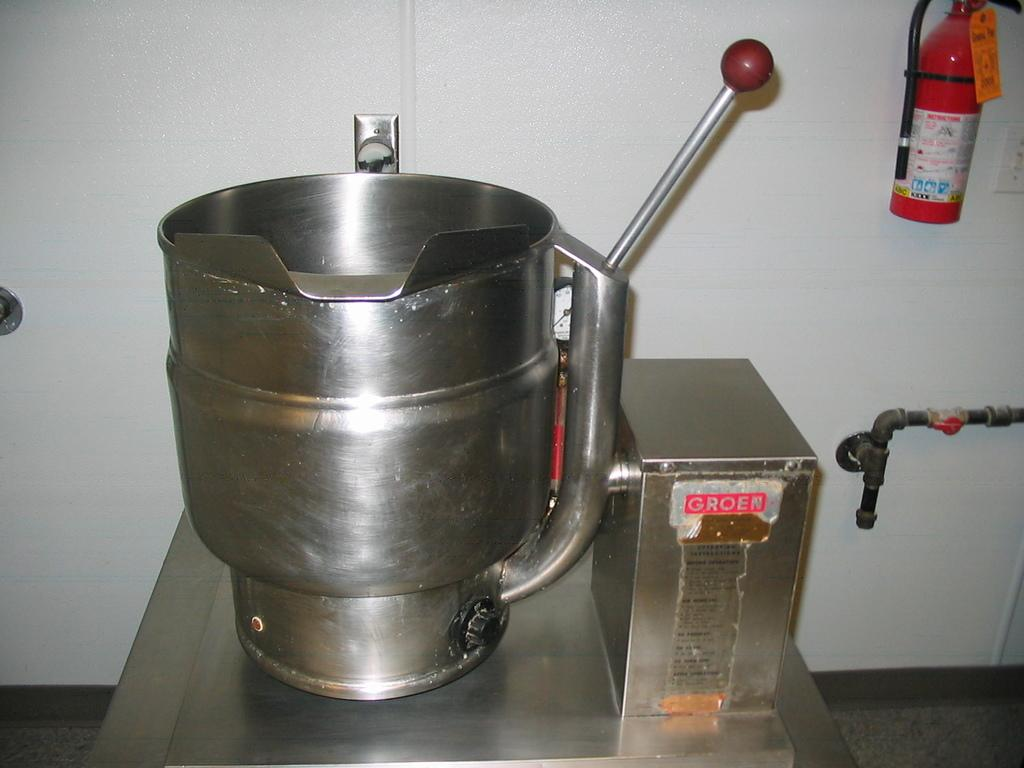<image>
Provide a brief description of the given image. A fire extinguisher next to a device with the word Groen 